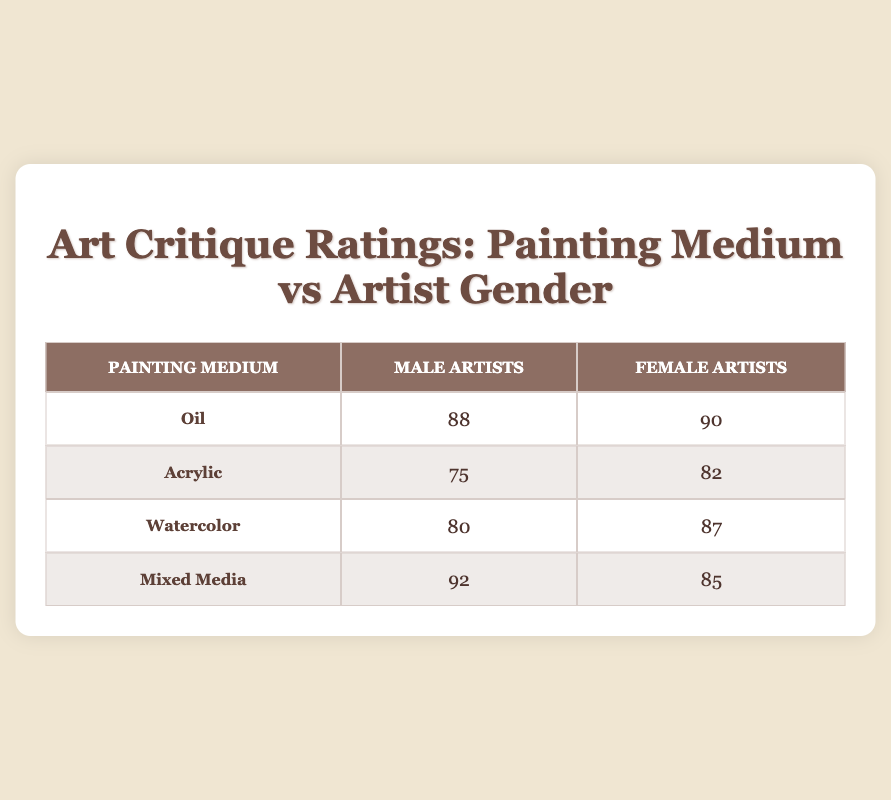What is the critique rating for male artists using Oil as their medium? The table shows that the critique rating for male artists using Oil is 88.
Answer: 88 What is the critique rating for female artists using Acrylic? From the table, the critique rating for female artists using Acrylic is 82.
Answer: 82 Which painting medium received the highest critique rating from male artists? Looking at the table, Mixed Media received the highest critique rating at 92 from male artists.
Answer: Mixed Media Is the critique rating for female artists generally higher than that for male artists across all mediums? By examining the table, female artists have higher ratings in Oil (90), Acrylic (82), Watercolor (87), and lower in Mixed Media (85 compared to 92). Hence, it is not true that female artists consistently have higher ratings.
Answer: No What is the average critique rating of male artists across all painting mediums? To find the average, sum the ratings for males: 88 (Oil) + 75 (Acrylic) + 80 (Watercolor) + 92 (Mixed Media) = 335. There are 4 ratings, so the average is 335 / 4 = 83.75.
Answer: 83.75 What is the difference between the highest and lowest critique ratings for female artists? The highest rating for female artists is 90 (Oil) and the lowest is 82 (Acrylic). The difference is 90 - 82 = 8.
Answer: 8 Which medium has the lowest critique rating for male artists? The table shows that Acrylic has the lowest critique rating for male artists, which is 75.
Answer: Acrylic Is the critique rating for Watercolor by female artists higher than Mixed Media by female artists? According to the table, the critiques are Watercolor (87) and Mixed Media (85). Since 87 is greater than 85, it confirms that the critique for Watercolor is higher.
Answer: Yes 